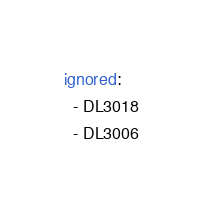<code> <loc_0><loc_0><loc_500><loc_500><_YAML_>ignored:
  - DL3018
  - DL3006
</code> 